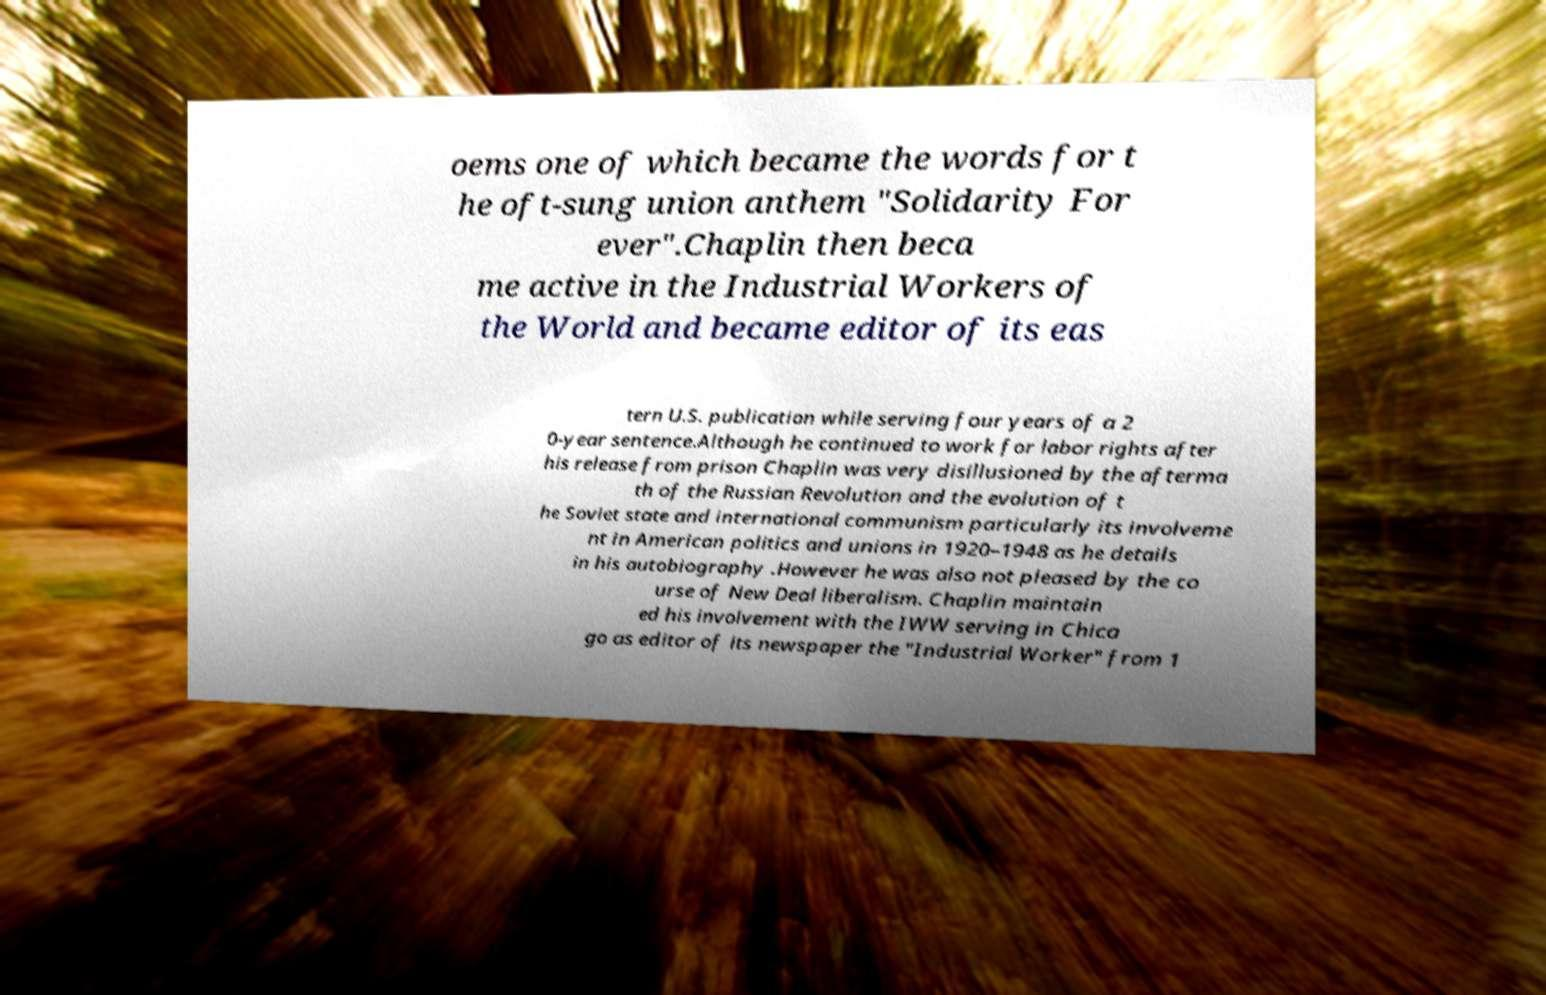Can you read and provide the text displayed in the image?This photo seems to have some interesting text. Can you extract and type it out for me? oems one of which became the words for t he oft-sung union anthem "Solidarity For ever".Chaplin then beca me active in the Industrial Workers of the World and became editor of its eas tern U.S. publication while serving four years of a 2 0-year sentence.Although he continued to work for labor rights after his release from prison Chaplin was very disillusioned by the afterma th of the Russian Revolution and the evolution of t he Soviet state and international communism particularly its involveme nt in American politics and unions in 1920–1948 as he details in his autobiography .However he was also not pleased by the co urse of New Deal liberalism. Chaplin maintain ed his involvement with the IWW serving in Chica go as editor of its newspaper the "Industrial Worker" from 1 